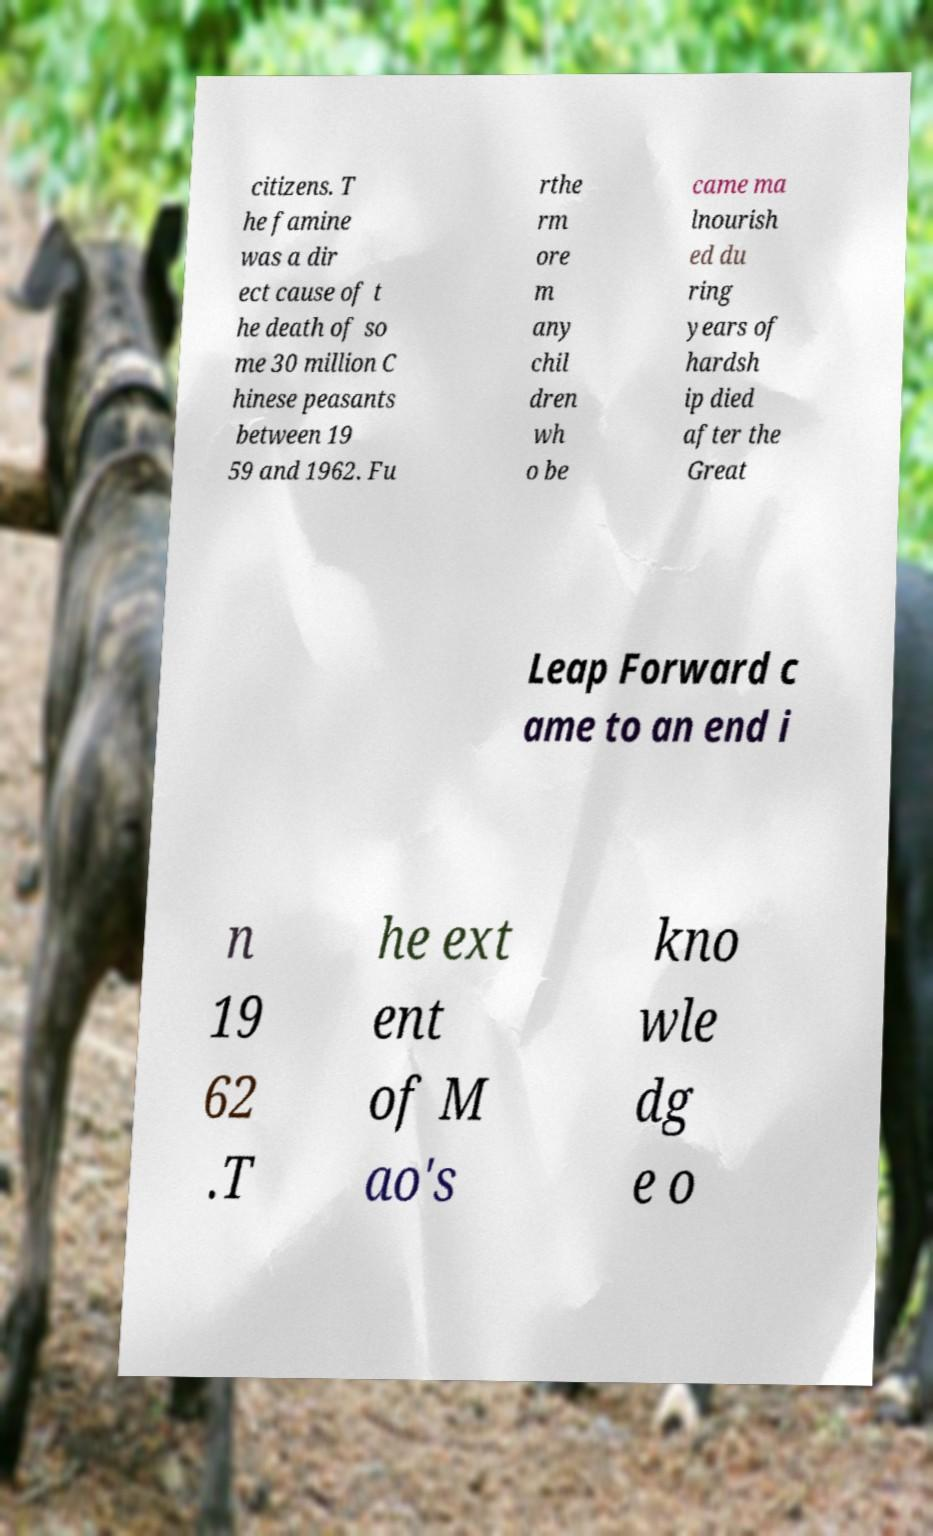Could you assist in decoding the text presented in this image and type it out clearly? citizens. T he famine was a dir ect cause of t he death of so me 30 million C hinese peasants between 19 59 and 1962. Fu rthe rm ore m any chil dren wh o be came ma lnourish ed du ring years of hardsh ip died after the Great Leap Forward c ame to an end i n 19 62 .T he ext ent of M ao's kno wle dg e o 